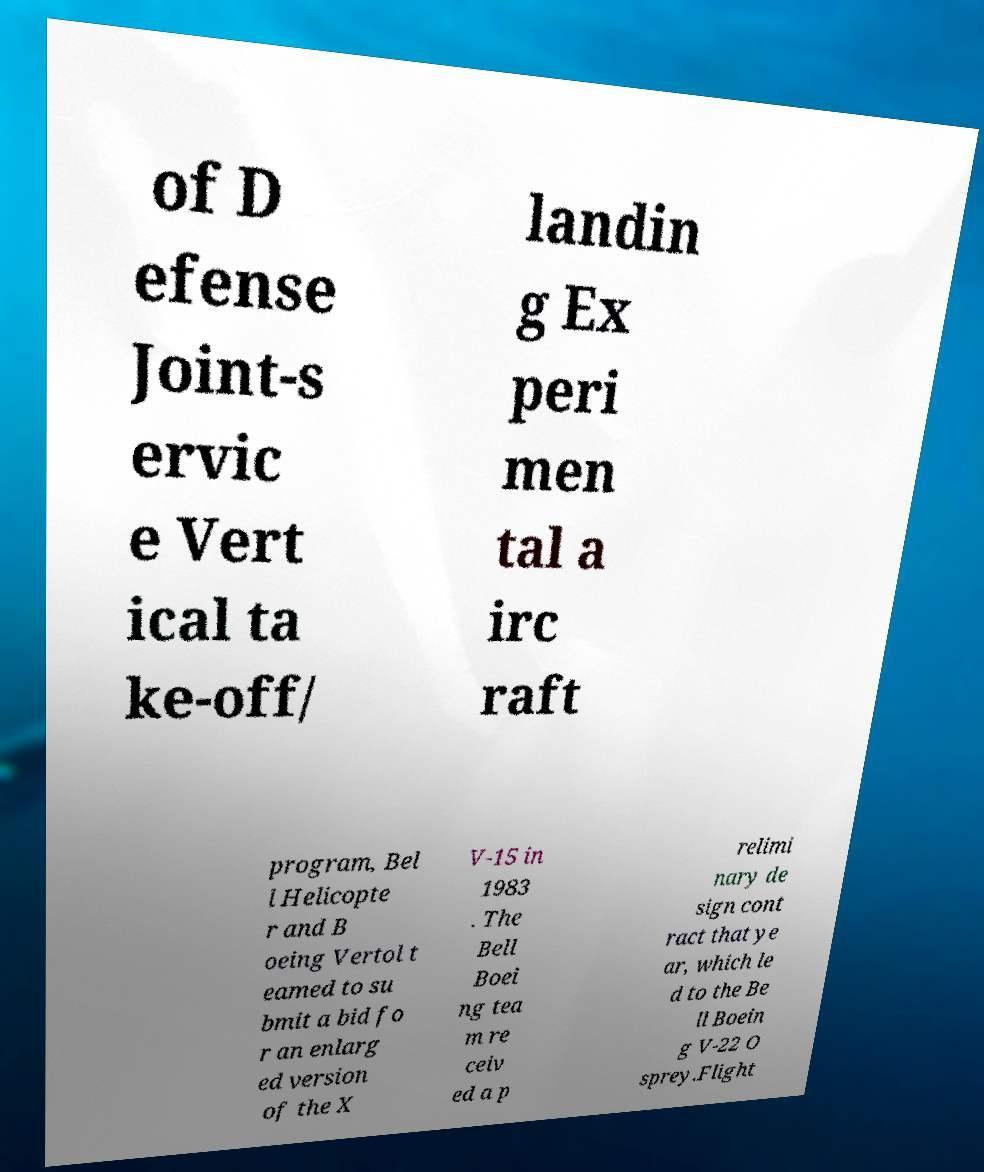Please read and relay the text visible in this image. What does it say? of D efense Joint-s ervic e Vert ical ta ke-off/ landin g Ex peri men tal a irc raft program, Bel l Helicopte r and B oeing Vertol t eamed to su bmit a bid fo r an enlarg ed version of the X V-15 in 1983 . The Bell Boei ng tea m re ceiv ed a p relimi nary de sign cont ract that ye ar, which le d to the Be ll Boein g V-22 O sprey.Flight 